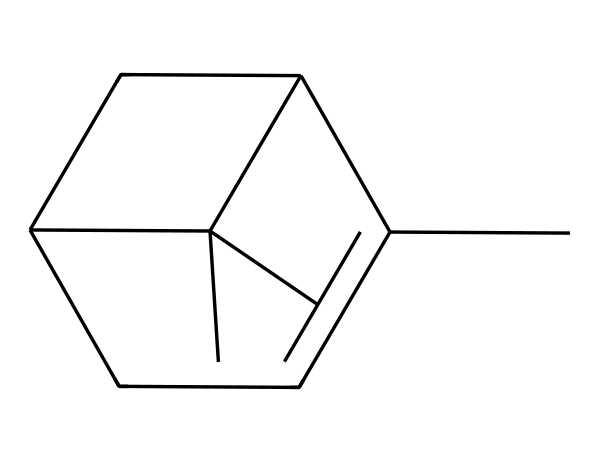What is the molecular formula of pinene? By analyzing its structure, we can count the carbon and hydrogen atoms present. There are 10 carbon atoms (C) and 16 hydrogen atoms (H), resulting in the molecular formula C10H16.
Answer: C10H16 How many rings are present in the structure of pinene? Observing the given SMILES representation, we note that there are two ring structures indicated by the numbers '1' and '2.' Therefore, pinene contains two rings.
Answer: 2 What is the primary functional group in pinene? The structure lacks the presence of indicative functional groups like hydroxyl or carboxyl groups. Pinene is primarily comprised of carbon-carbon bonds, thus classifying it as a hydrocarbon and specifically a terpene without additional functional groups.
Answer: hydrocarbon How many double bonds are found in pinene? By examining the structure, we can deduce that there is one double bond connecting the carbon atoms, characteristic of terpenes. This can be identified by the connectivity in the ring structure and the SMILES notation.
Answer: 1 Is pinene considered a cyclic compound? The presence of ring structures in the molecule confirms that pinene is indeed a cyclic compound, making it part of the class of monocyclic terpenes.
Answer: yes Which type of terpene is pinene? Pinene is categorized as a bicyclic monoterpene due to its structure, which includes a bicyclic arrangement of carbon atoms containing ten carbon atoms in total.
Answer: bicyclic monoterpene What type of vapor phase is pinene likely to produce? Due to its few functional groups and overall hydrocarbon composition, pinene can readily evaporate at room temperature, producing a strong aromatic vapor characteristic of its fresh pine scent.
Answer: aromatic vapor 